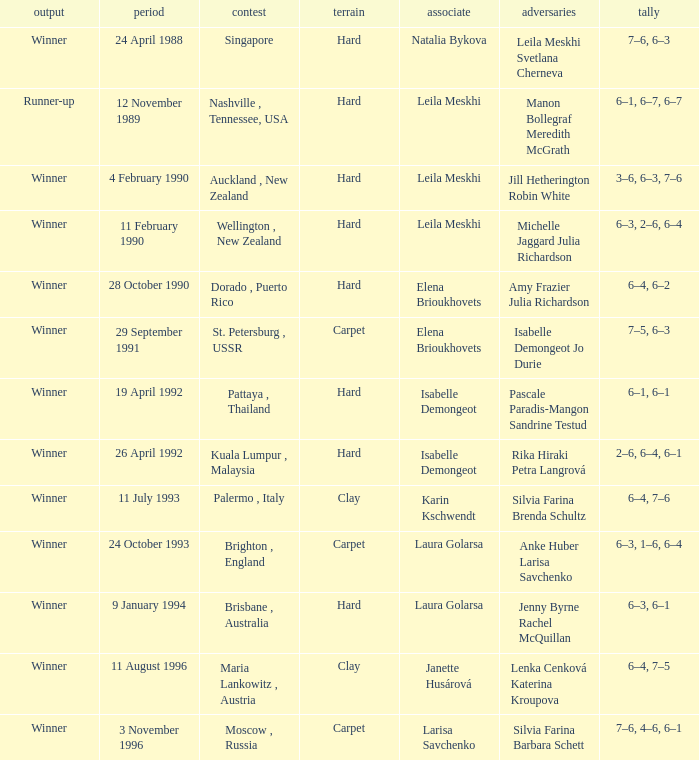On what Date was the Score 6–4, 6–2? 28 October 1990. 